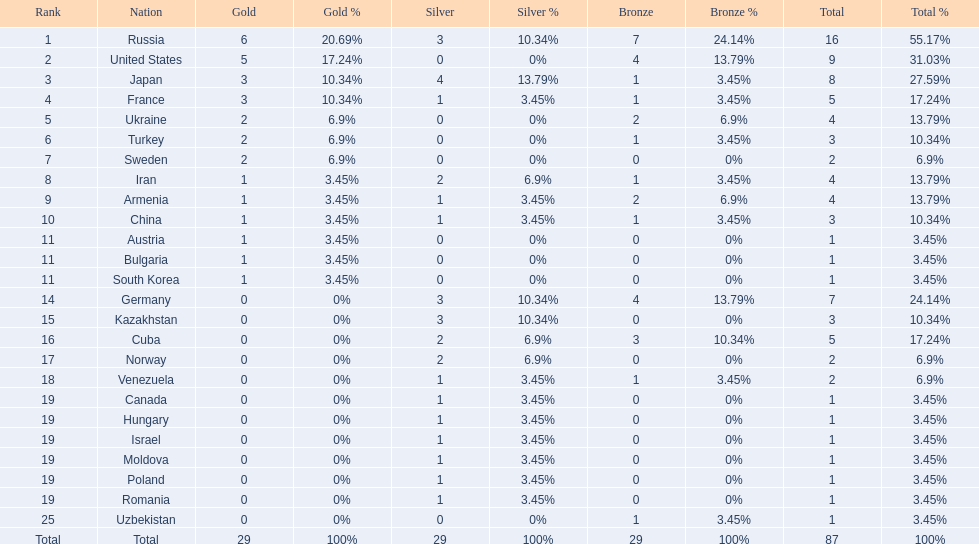Which nations only won less then 5 medals? Ukraine, Turkey, Sweden, Iran, Armenia, China, Austria, Bulgaria, South Korea, Germany, Kazakhstan, Norway, Venezuela, Canada, Hungary, Israel, Moldova, Poland, Romania, Uzbekistan. Which of these were not asian nations? Ukraine, Turkey, Sweden, Iran, Armenia, Austria, Bulgaria, Germany, Kazakhstan, Norway, Venezuela, Canada, Hungary, Israel, Moldova, Poland, Romania, Uzbekistan. Which of those did not win any silver medals? Ukraine, Turkey, Sweden, Austria, Bulgaria, Uzbekistan. Which ones of these had only one medal total? Austria, Bulgaria, Uzbekistan. Which of those would be listed first alphabetically? Austria. 